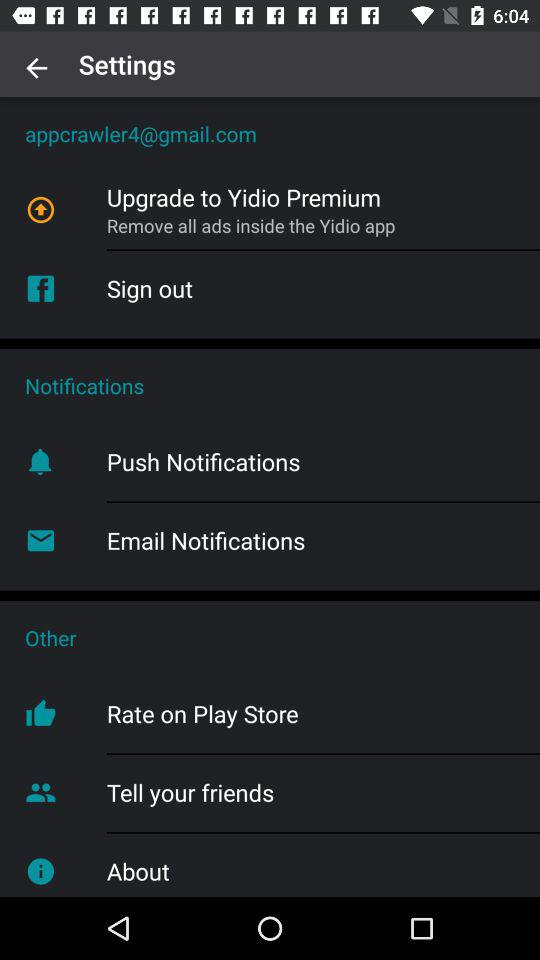How many items are in the Other section?
Answer the question using a single word or phrase. 3 